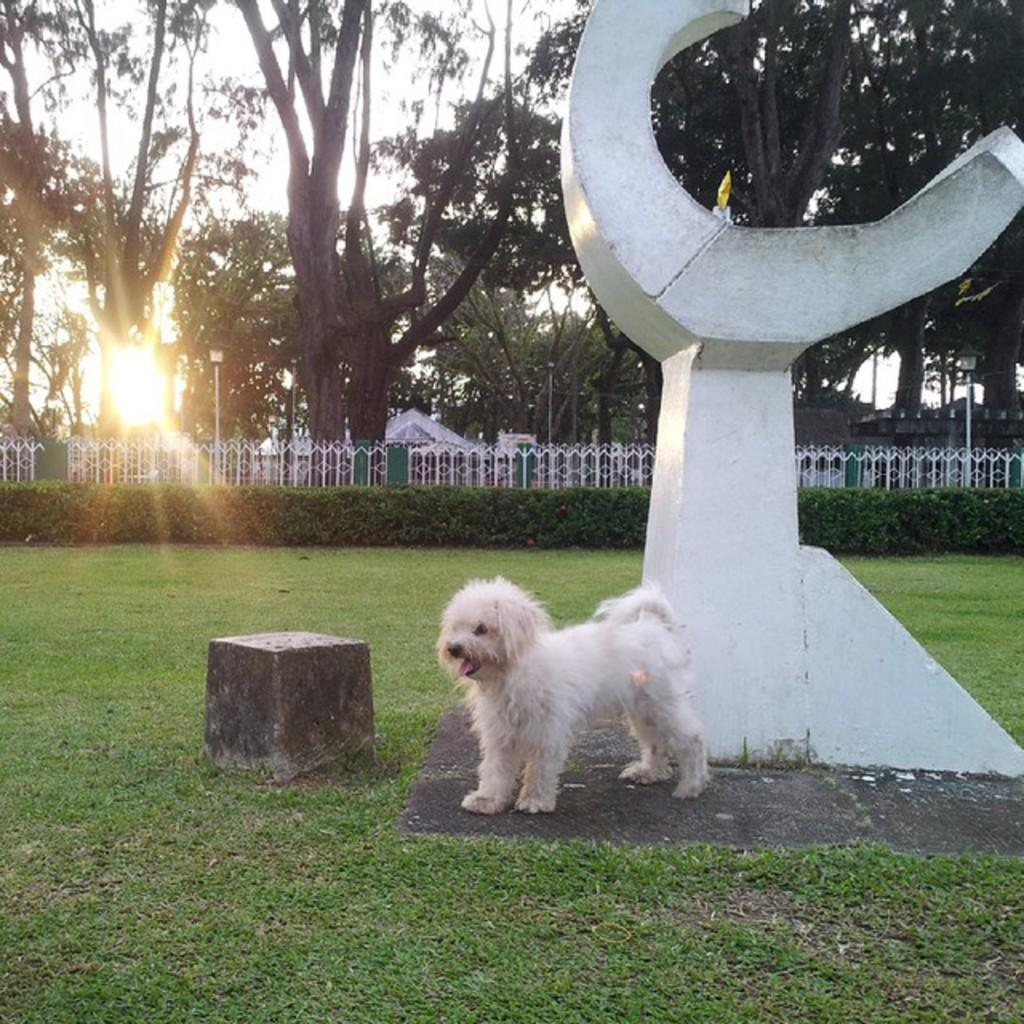What type of animal can be seen on the ground in the image? There is a dog on the ground in the image. What is located on the right side of the image? There is a statue on the right side of the image. What can be seen in the background of the image? There is a fence, a group of poles, trees, and the sky visible in the background of the image. What type of cat is sitting on the unit in the image? There is no cat or unit present in the image. What scale is used to measure the distance between the poles in the image? There is no scale or measurement of distance between the poles in the image; they are simply visible in the background. 